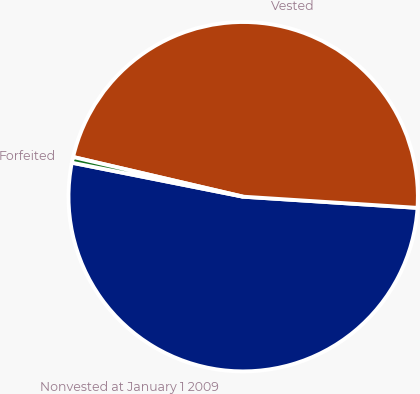<chart> <loc_0><loc_0><loc_500><loc_500><pie_chart><fcel>Nonvested at January 1 2009<fcel>Vested<fcel>Forfeited<nl><fcel>52.1%<fcel>47.37%<fcel>0.53%<nl></chart> 